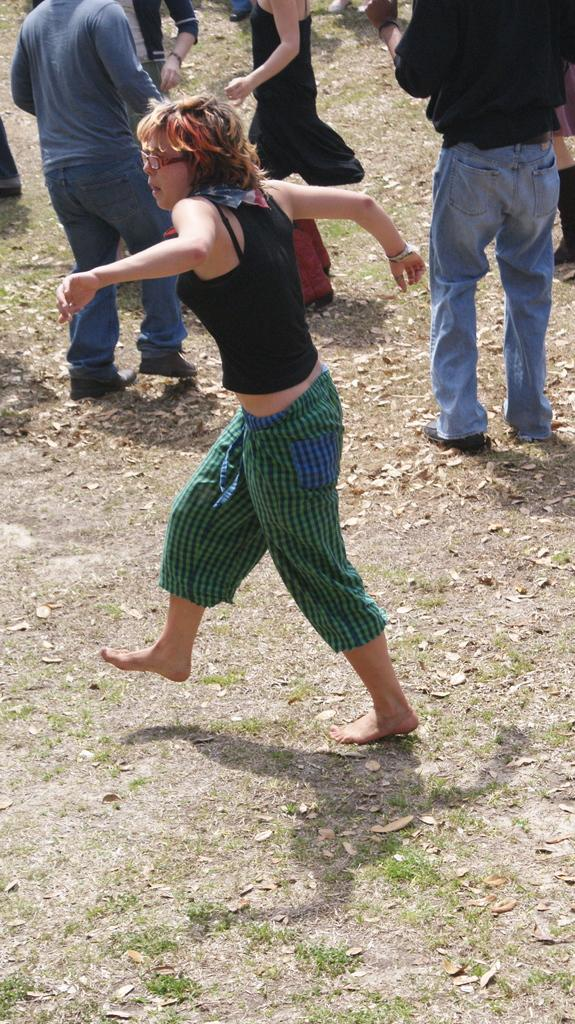How many people are in the image? There are people in the image, but the exact number is not specified. What is one of the people doing in the image? There is a person running in the image. What type of terrain is visible in the image? There is grass visible in the image. What else can be seen in the image besides people and grass? Leaves are present in the image. Can you tell me how many times the person running in the image bites their nails? There is no information about nail-biting in the image, so it cannot be determined. 